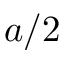Convert formula to latex. <formula><loc_0><loc_0><loc_500><loc_500>a / 2</formula> 